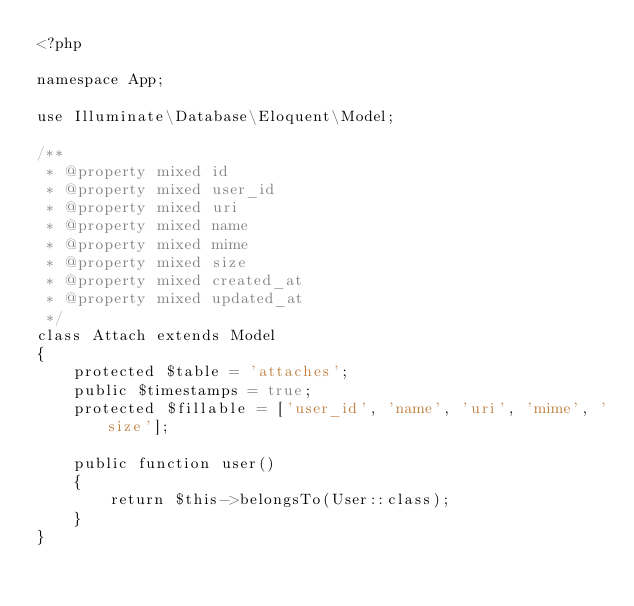Convert code to text. <code><loc_0><loc_0><loc_500><loc_500><_PHP_><?php

namespace App;

use Illuminate\Database\Eloquent\Model;

/**
 * @property mixed id
 * @property mixed user_id
 * @property mixed uri
 * @property mixed name
 * @property mixed mime
 * @property mixed size
 * @property mixed created_at
 * @property mixed updated_at
 */
class Attach extends Model
{
    protected $table = 'attaches';
    public $timestamps = true;
    protected $fillable = ['user_id', 'name', 'uri', 'mime', 'size'];

    public function user()
    {
        return $this->belongsTo(User::class);
    }
}
</code> 